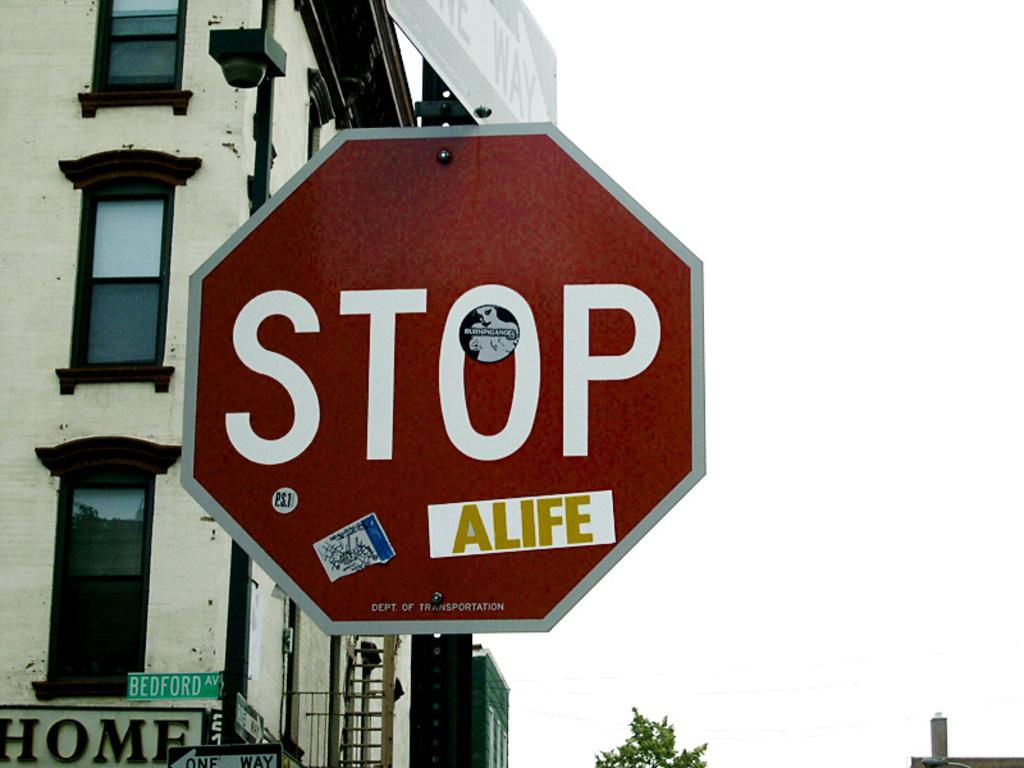<image>
Summarize the visual content of the image. A stop sign near a sign for Bedford Avenue is covered with stickers. 